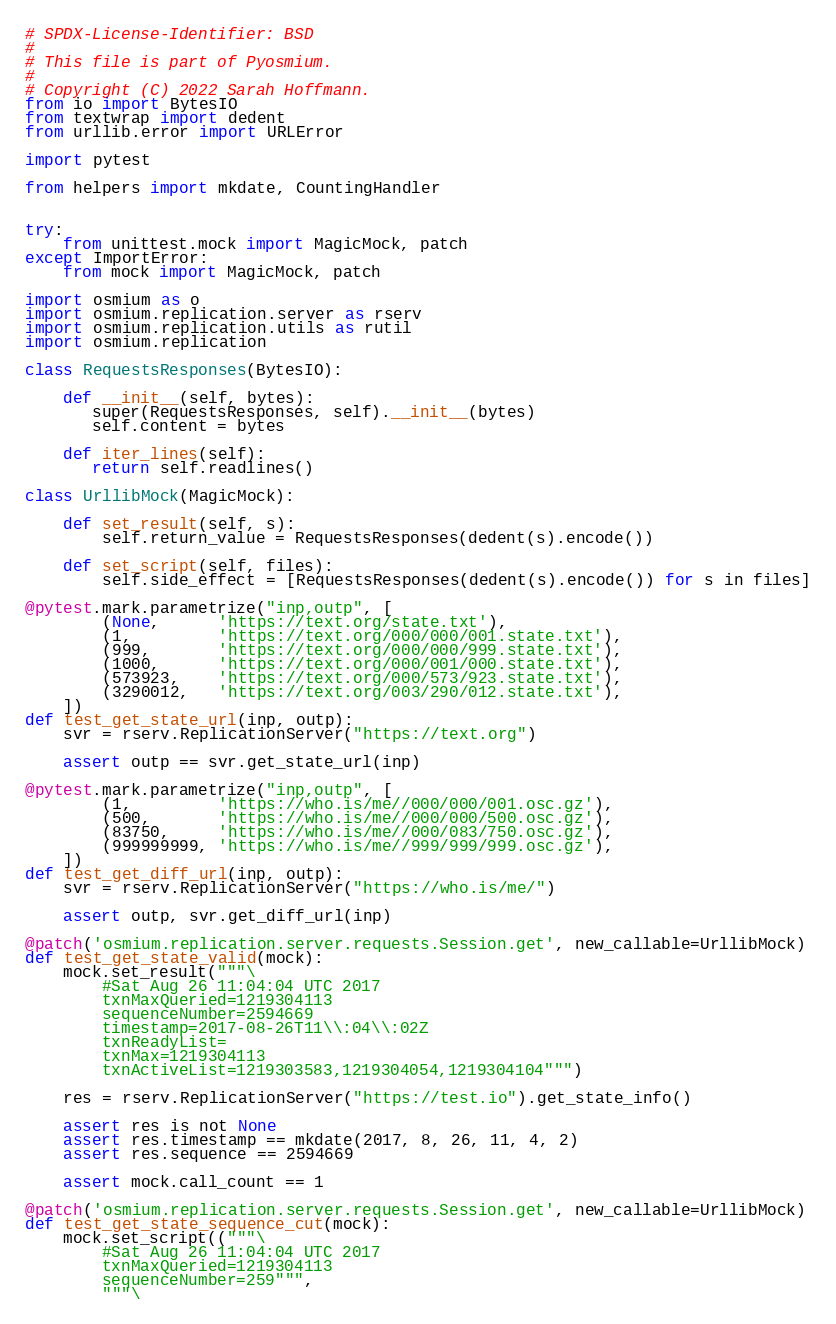Convert code to text. <code><loc_0><loc_0><loc_500><loc_500><_Python_># SPDX-License-Identifier: BSD
#
# This file is part of Pyosmium.
#
# Copyright (C) 2022 Sarah Hoffmann.
from io import BytesIO
from textwrap import dedent
from urllib.error import URLError

import pytest

from helpers import mkdate, CountingHandler


try:
    from unittest.mock import MagicMock, patch
except ImportError:
    from mock import MagicMock, patch

import osmium as o
import osmium.replication.server as rserv
import osmium.replication.utils as rutil
import osmium.replication

class RequestsResponses(BytesIO):

    def __init__(self, bytes):
       super(RequestsResponses, self).__init__(bytes)
       self.content = bytes

    def iter_lines(self):
       return self.readlines()

class UrllibMock(MagicMock):

    def set_result(self, s):
        self.return_value = RequestsResponses(dedent(s).encode())

    def set_script(self, files):
        self.side_effect = [RequestsResponses(dedent(s).encode()) for s in files]

@pytest.mark.parametrize("inp,outp", [
        (None,      'https://text.org/state.txt'),
        (1,         'https://text.org/000/000/001.state.txt'),
        (999,       'https://text.org/000/000/999.state.txt'),
        (1000,      'https://text.org/000/001/000.state.txt'),
        (573923,    'https://text.org/000/573/923.state.txt'),
        (3290012,   'https://text.org/003/290/012.state.txt'),
    ])
def test_get_state_url(inp, outp):
    svr = rserv.ReplicationServer("https://text.org")

    assert outp == svr.get_state_url(inp)

@pytest.mark.parametrize("inp,outp", [
        (1,         'https://who.is/me//000/000/001.osc.gz'),
        (500,       'https://who.is/me//000/000/500.osc.gz'),
        (83750,     'https://who.is/me//000/083/750.osc.gz'),
        (999999999, 'https://who.is/me//999/999/999.osc.gz'),
    ])
def test_get_diff_url(inp, outp):
    svr = rserv.ReplicationServer("https://who.is/me/")

    assert outp, svr.get_diff_url(inp)

@patch('osmium.replication.server.requests.Session.get', new_callable=UrllibMock)
def test_get_state_valid(mock):
    mock.set_result("""\
        #Sat Aug 26 11:04:04 UTC 2017
        txnMaxQueried=1219304113
        sequenceNumber=2594669
        timestamp=2017-08-26T11\\:04\\:02Z
        txnReadyList=
        txnMax=1219304113
        txnActiveList=1219303583,1219304054,1219304104""")

    res = rserv.ReplicationServer("https://test.io").get_state_info()

    assert res is not None
    assert res.timestamp == mkdate(2017, 8, 26, 11, 4, 2)
    assert res.sequence == 2594669

    assert mock.call_count == 1

@patch('osmium.replication.server.requests.Session.get', new_callable=UrllibMock)
def test_get_state_sequence_cut(mock):
    mock.set_script(("""\
        #Sat Aug 26 11:04:04 UTC 2017
        txnMaxQueried=1219304113
        sequenceNumber=259""",
        """\</code> 